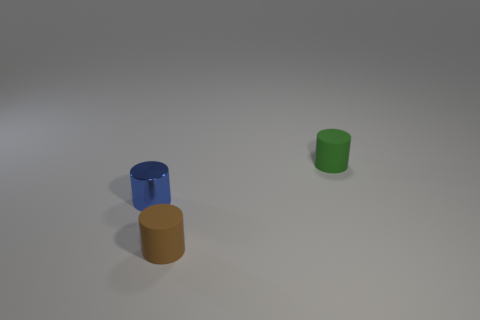Do the small green object and the cylinder that is to the left of the small brown cylinder have the same material?
Your answer should be compact. No. What number of tiny brown cylinders are in front of the shiny cylinder?
Give a very brief answer. 1. What material is the green thing?
Your response must be concise. Rubber. Are there fewer small blue objects that are behind the brown rubber cylinder than tiny matte cylinders?
Your answer should be compact. Yes. What color is the matte thing on the left side of the green matte cylinder?
Provide a succinct answer. Brown. There is a brown object; what shape is it?
Provide a short and direct response. Cylinder. Are there any tiny green cylinders behind the brown object that is in front of the tiny blue metal thing that is behind the tiny brown rubber thing?
Provide a succinct answer. Yes. The object that is to the left of the tiny brown thing that is left of the thing behind the small blue metal cylinder is what color?
Your answer should be compact. Blue. There is a blue object that is the same shape as the small green rubber object; what is its material?
Keep it short and to the point. Metal. What material is the small cylinder that is on the right side of the brown matte object?
Offer a very short reply. Rubber. 